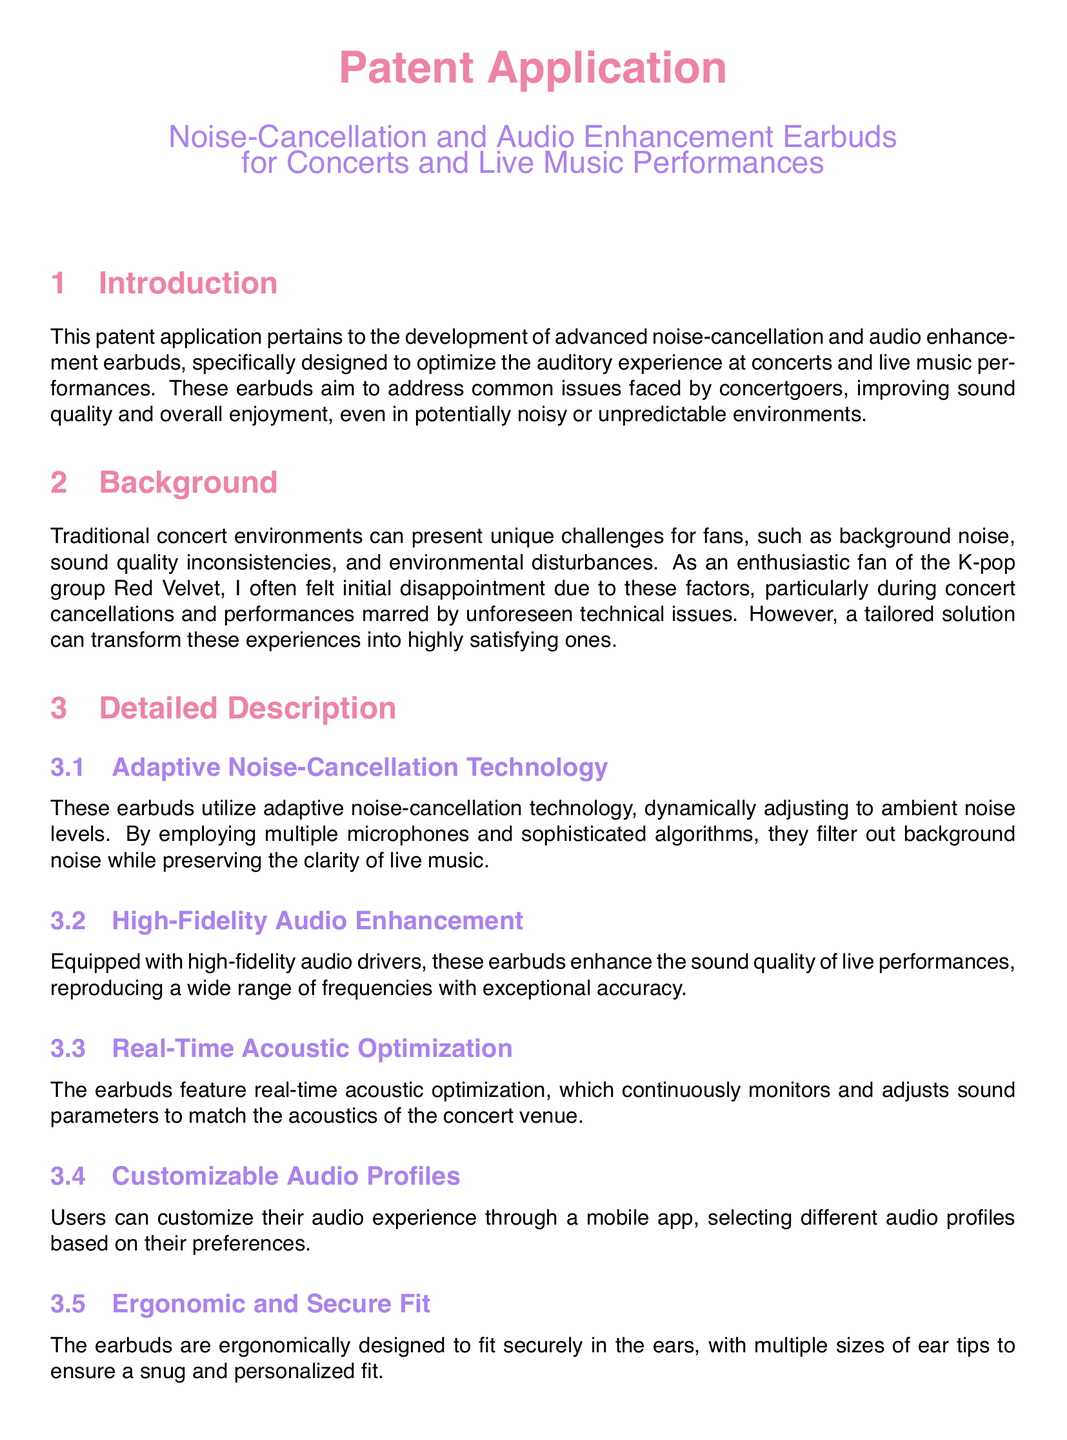What is the main purpose of the patent application? The main purpose of the patent application is to develop advanced noise-cancellation and audio enhancement earbuds designed to optimize the auditory experience at concerts and live music performances.
Answer: optimize the auditory experience What technology do the earbuds utilize for noise cancellation? The earbuds utilize adaptive noise-cancellation technology.
Answer: adaptive noise-cancellation technology How many features does the claims section describe? The claims section describes a total of six features.
Answer: six What allows users to personalize their listening experience? Users can personalize their listening experience through customizable audio profiles in a mobile app.
Answer: customizable audio profiles What is one key benefit of the earbuds' ergonomic design? The ergonomic design ensures a comfortable and secure fit for prolonged use.
Answer: comfortable and secure fit Which section addresses the challenges faced by concertgoers? The section that addresses the challenges faced by concertgoers is the Background section.
Answer: Background section What does the extended battery life support? The extended battery life supports uninterrupted playback throughout the event.
Answer: uninterrupted playback What key feature helps maintain sound quality at varying concert venues? Real-time acoustic optimization helps maintain sound quality at varying concert venues.
Answer: Real-time acoustic optimization 